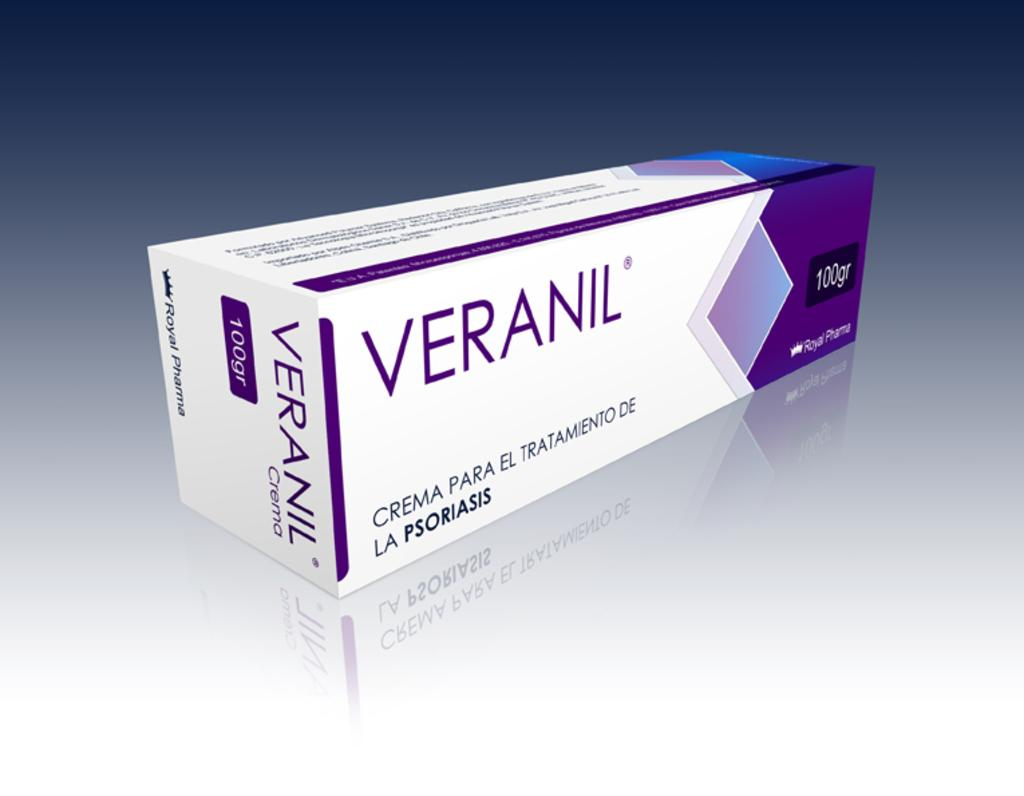<image>
Describe the image concisely. A white and purple box of Veranil contains 100 grams. 